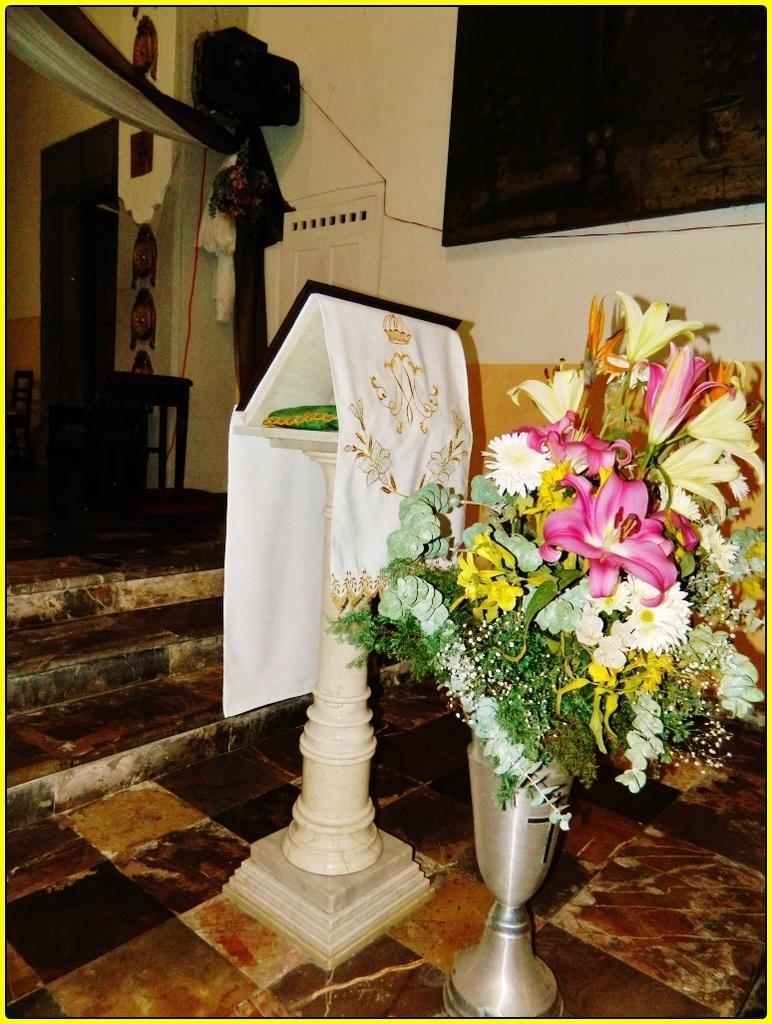Could you give a brief overview of what you see in this image? It looks like an edited image. I can see a flower vase with a bunch of colorful flowers. This looks like a stand with a board and a cloth on it. These are the stairs. At the top of the image, I can see a cloth hanging. In the background, I can see a stool, doors and few other objects. At the top right side of the image, that looks like a frame, which is attached to a wall. 